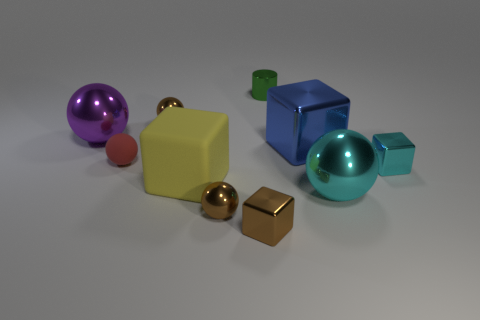Is the metallic cylinder the same color as the large metal block?
Give a very brief answer. No. What material is the sphere in front of the large sphere to the right of the tiny metal cylinder?
Your answer should be compact. Metal. There is a large cyan thing that is the same shape as the red matte thing; what is its material?
Give a very brief answer. Metal. Are there any rubber spheres in front of the small brown block that is in front of the tiny cube that is right of the big blue cube?
Your answer should be very brief. No. How many shiny things are in front of the green cylinder and on the left side of the cyan cube?
Provide a short and direct response. 6. There is a blue shiny object; what shape is it?
Offer a terse response. Cube. What number of other things are made of the same material as the tiny red sphere?
Your response must be concise. 1. The small cube that is to the left of the small metal cube that is on the right side of the shiny block on the left side of the cylinder is what color?
Keep it short and to the point. Brown. There is another block that is the same size as the brown cube; what is its material?
Make the answer very short. Metal. What number of things are small cubes to the right of the small green cylinder or small blue shiny objects?
Make the answer very short. 1. 